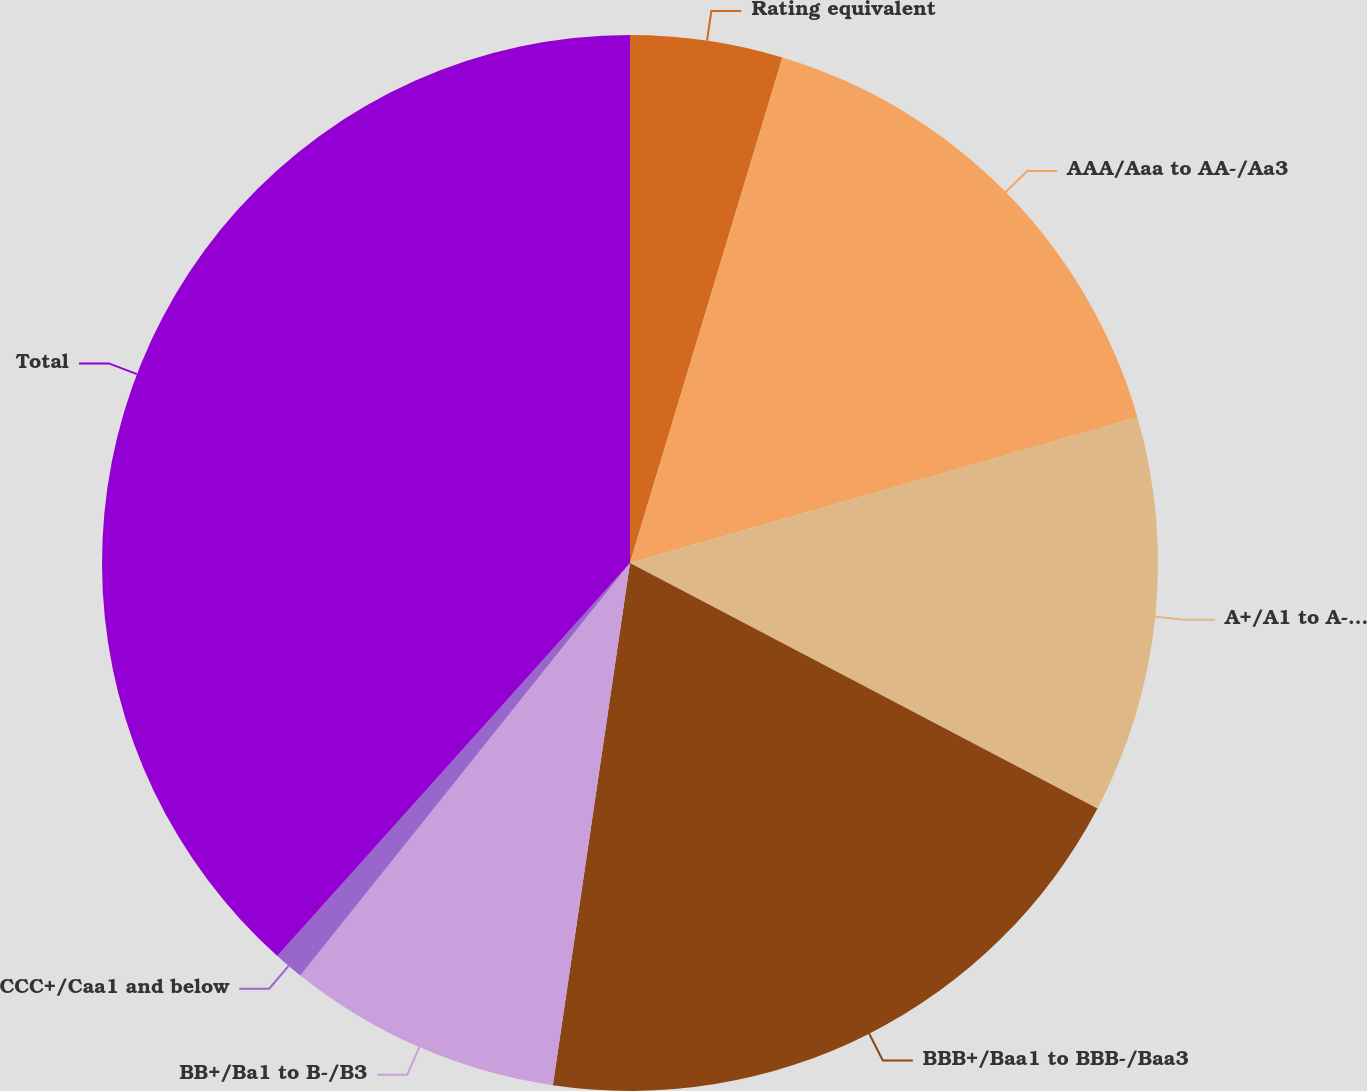Convert chart to OTSL. <chart><loc_0><loc_0><loc_500><loc_500><pie_chart><fcel>Rating equivalent<fcel>AAA/Aaa to AA-/Aa3<fcel>A+/A1 to A-/A3<fcel>BBB+/Baa1 to BBB-/Baa3<fcel>BB+/Ba1 to B-/B3<fcel>CCC+/Caa1 and below<fcel>Total<nl><fcel>4.66%<fcel>15.89%<fcel>12.15%<fcel>19.64%<fcel>8.4%<fcel>0.91%<fcel>38.36%<nl></chart> 